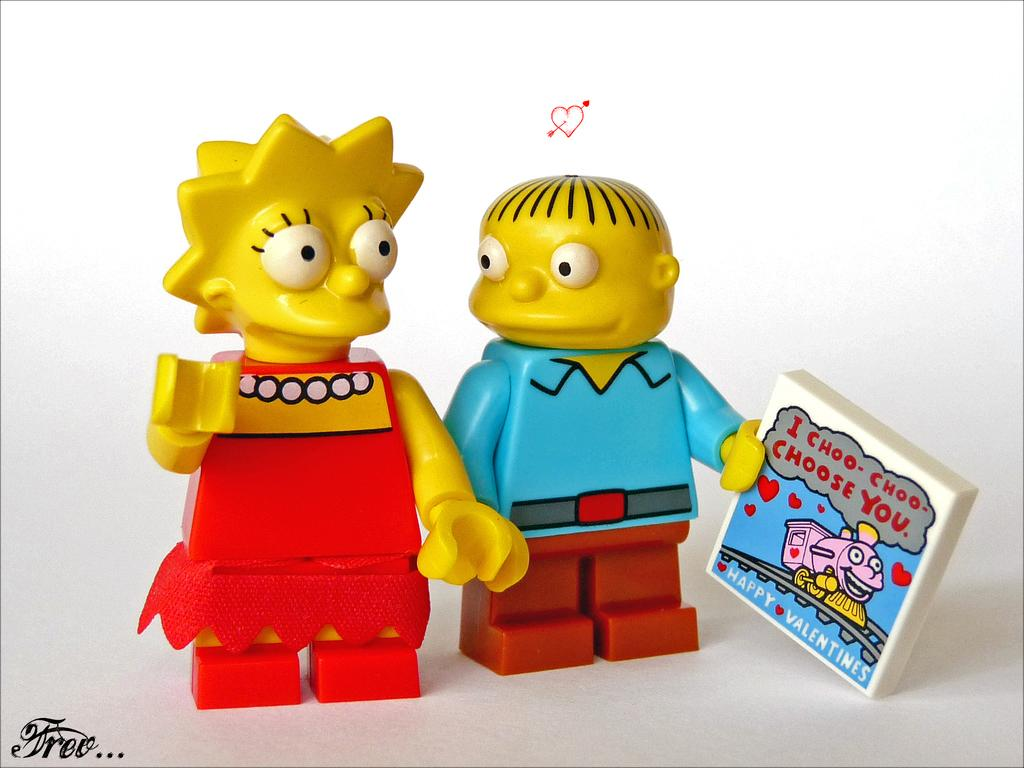What is located in the middle of the image? There are dolls in the middle of the image. Is there any text present in the image? Yes, there is text in the bottom left-hand side of the image. What type of smell can be detected from the dolls in the image? There is no information about any smell in the image, as it only features dolls and text. 